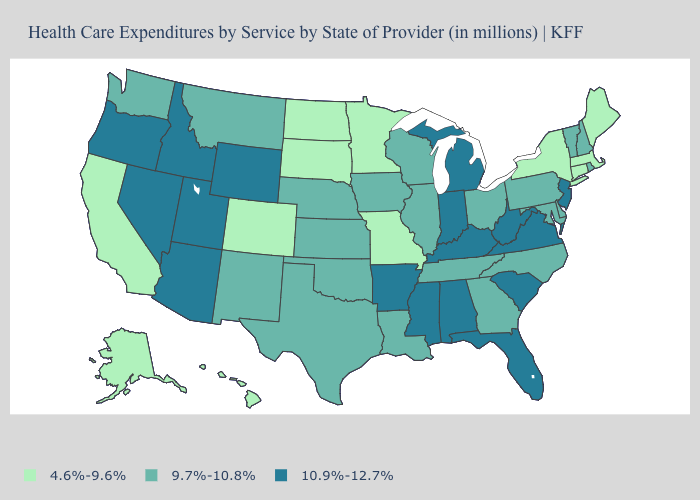Does the map have missing data?
Keep it brief. No. Does Florida have the highest value in the South?
Quick response, please. Yes. Which states hav the highest value in the West?
Short answer required. Arizona, Idaho, Nevada, Oregon, Utah, Wyoming. What is the highest value in the USA?
Short answer required. 10.9%-12.7%. What is the value of Ohio?
Give a very brief answer. 9.7%-10.8%. What is the lowest value in states that border Maryland?
Concise answer only. 9.7%-10.8%. Among the states that border Delaware , does New Jersey have the highest value?
Be succinct. Yes. Among the states that border Virginia , does North Carolina have the highest value?
Be succinct. No. How many symbols are there in the legend?
Write a very short answer. 3. Name the states that have a value in the range 9.7%-10.8%?
Concise answer only. Delaware, Georgia, Illinois, Iowa, Kansas, Louisiana, Maryland, Montana, Nebraska, New Hampshire, New Mexico, North Carolina, Ohio, Oklahoma, Pennsylvania, Rhode Island, Tennessee, Texas, Vermont, Washington, Wisconsin. Does West Virginia have the same value as Mississippi?
Give a very brief answer. Yes. Does Texas have the same value as Washington?
Quick response, please. Yes. What is the highest value in the Northeast ?
Quick response, please. 10.9%-12.7%. Name the states that have a value in the range 4.6%-9.6%?
Write a very short answer. Alaska, California, Colorado, Connecticut, Hawaii, Maine, Massachusetts, Minnesota, Missouri, New York, North Dakota, South Dakota. Name the states that have a value in the range 4.6%-9.6%?
Short answer required. Alaska, California, Colorado, Connecticut, Hawaii, Maine, Massachusetts, Minnesota, Missouri, New York, North Dakota, South Dakota. 